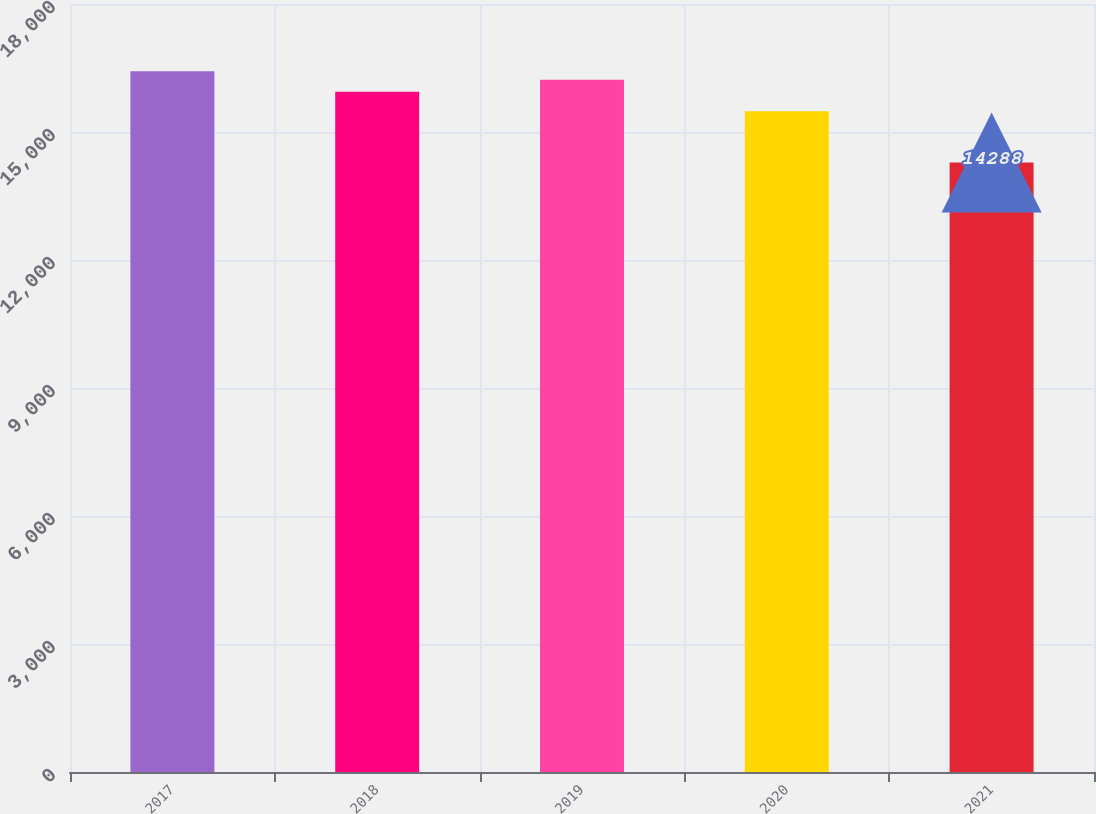<chart> <loc_0><loc_0><loc_500><loc_500><bar_chart><fcel>2017<fcel>2018<fcel>2019<fcel>2020<fcel>2021<nl><fcel>16424<fcel>15941<fcel>16222<fcel>15488<fcel>14288<nl></chart> 